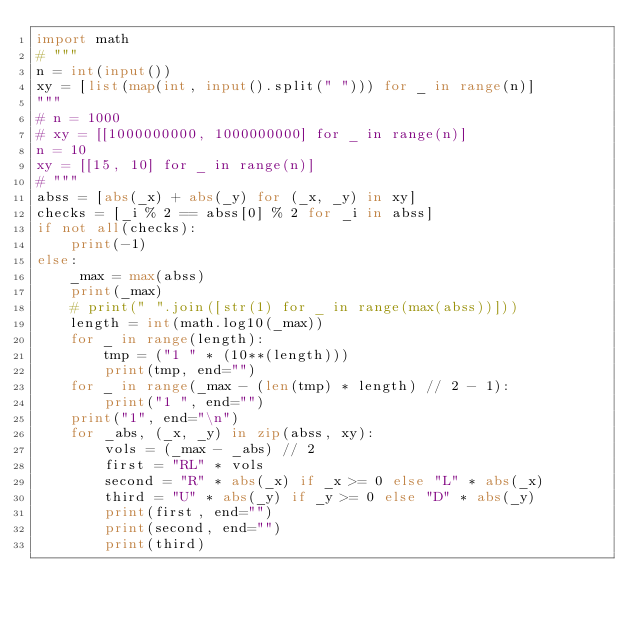Convert code to text. <code><loc_0><loc_0><loc_500><loc_500><_Python_>import math
# """
n = int(input())
xy = [list(map(int, input().split(" "))) for _ in range(n)]
"""
# n = 1000
# xy = [[1000000000, 1000000000] for _ in range(n)]
n = 10
xy = [[15, 10] for _ in range(n)]
# """
abss = [abs(_x) + abs(_y) for (_x, _y) in xy]
checks = [_i % 2 == abss[0] % 2 for _i in abss]
if not all(checks):
    print(-1)
else:
    _max = max(abss)
    print(_max)
    # print(" ".join([str(1) for _ in range(max(abss))]))
    length = int(math.log10(_max))
    for _ in range(length):
        tmp = ("1 " * (10**(length)))
        print(tmp, end="")
    for _ in range(_max - (len(tmp) * length) // 2 - 1):
        print("1 ", end="")
    print("1", end="\n")
    for _abs, (_x, _y) in zip(abss, xy):
        vols = (_max - _abs) // 2
        first = "RL" * vols
        second = "R" * abs(_x) if _x >= 0 else "L" * abs(_x)
        third = "U" * abs(_y) if _y >= 0 else "D" * abs(_y)
        print(first, end="")
        print(second, end="")
        print(third)

</code> 